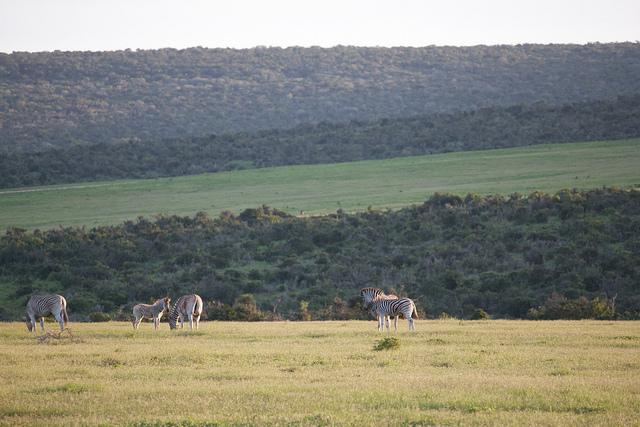What are the zebras looking at on the grass? food 